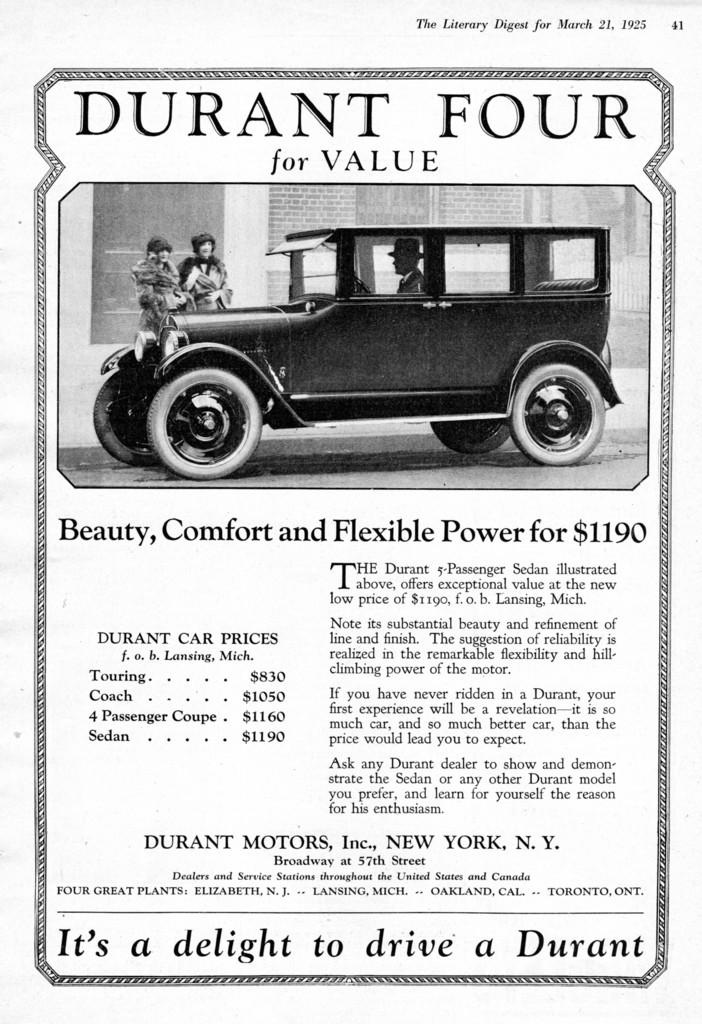What can be seen in the picture? There are images and text in the picture. Can you describe the images in the picture? Unfortunately, the provided facts do not give specific details about the images in the picture. What does the text in the picture say? The provided facts do not give specific details about the text in the picture. How many rabbits are wearing shoes in the picture? There are no rabbits or shoes present in the picture, as stated in the provided facts. 